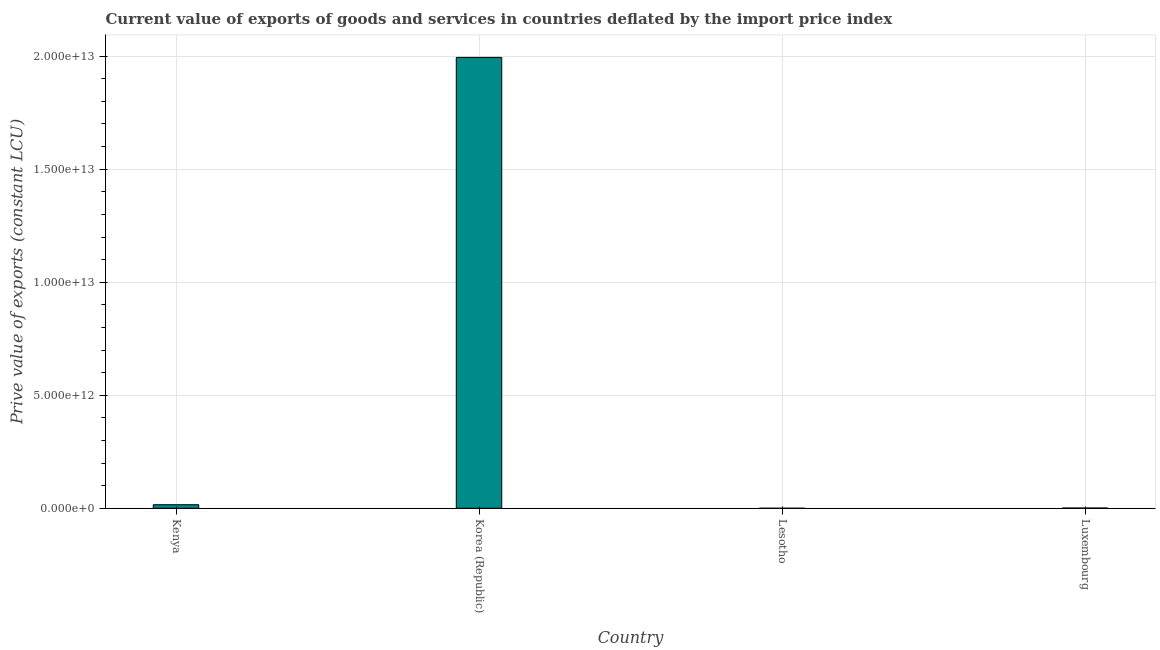What is the title of the graph?
Your answer should be compact. Current value of exports of goods and services in countries deflated by the import price index. What is the label or title of the X-axis?
Offer a terse response. Country. What is the label or title of the Y-axis?
Keep it short and to the point. Prive value of exports (constant LCU). What is the price value of exports in Lesotho?
Your response must be concise. 6.41e+08. Across all countries, what is the maximum price value of exports?
Your answer should be compact. 1.99e+13. Across all countries, what is the minimum price value of exports?
Give a very brief answer. 6.41e+08. In which country was the price value of exports maximum?
Make the answer very short. Korea (Republic). In which country was the price value of exports minimum?
Offer a very short reply. Lesotho. What is the sum of the price value of exports?
Offer a terse response. 2.01e+13. What is the difference between the price value of exports in Korea (Republic) and Luxembourg?
Make the answer very short. 1.99e+13. What is the average price value of exports per country?
Give a very brief answer. 5.03e+12. What is the median price value of exports?
Provide a succinct answer. 8.36e+1. What is the ratio of the price value of exports in Kenya to that in Luxembourg?
Offer a very short reply. 14.62. What is the difference between the highest and the second highest price value of exports?
Make the answer very short. 1.98e+13. Is the sum of the price value of exports in Kenya and Luxembourg greater than the maximum price value of exports across all countries?
Give a very brief answer. No. What is the difference between the highest and the lowest price value of exports?
Your response must be concise. 1.99e+13. In how many countries, is the price value of exports greater than the average price value of exports taken over all countries?
Your answer should be compact. 1. How many bars are there?
Provide a succinct answer. 4. Are all the bars in the graph horizontal?
Keep it short and to the point. No. What is the difference between two consecutive major ticks on the Y-axis?
Provide a short and direct response. 5.00e+12. What is the Prive value of exports (constant LCU) in Kenya?
Your answer should be very brief. 1.57e+11. What is the Prive value of exports (constant LCU) of Korea (Republic)?
Your answer should be very brief. 1.99e+13. What is the Prive value of exports (constant LCU) of Lesotho?
Your answer should be very brief. 6.41e+08. What is the Prive value of exports (constant LCU) in Luxembourg?
Give a very brief answer. 1.07e+1. What is the difference between the Prive value of exports (constant LCU) in Kenya and Korea (Republic)?
Offer a terse response. -1.98e+13. What is the difference between the Prive value of exports (constant LCU) in Kenya and Lesotho?
Your answer should be compact. 1.56e+11. What is the difference between the Prive value of exports (constant LCU) in Kenya and Luxembourg?
Give a very brief answer. 1.46e+11. What is the difference between the Prive value of exports (constant LCU) in Korea (Republic) and Lesotho?
Provide a succinct answer. 1.99e+13. What is the difference between the Prive value of exports (constant LCU) in Korea (Republic) and Luxembourg?
Your response must be concise. 1.99e+13. What is the difference between the Prive value of exports (constant LCU) in Lesotho and Luxembourg?
Your response must be concise. -1.01e+1. What is the ratio of the Prive value of exports (constant LCU) in Kenya to that in Korea (Republic)?
Provide a succinct answer. 0.01. What is the ratio of the Prive value of exports (constant LCU) in Kenya to that in Lesotho?
Provide a short and direct response. 244.22. What is the ratio of the Prive value of exports (constant LCU) in Kenya to that in Luxembourg?
Make the answer very short. 14.62. What is the ratio of the Prive value of exports (constant LCU) in Korea (Republic) to that in Lesotho?
Provide a short and direct response. 3.11e+04. What is the ratio of the Prive value of exports (constant LCU) in Korea (Republic) to that in Luxembourg?
Provide a short and direct response. 1862.48. 